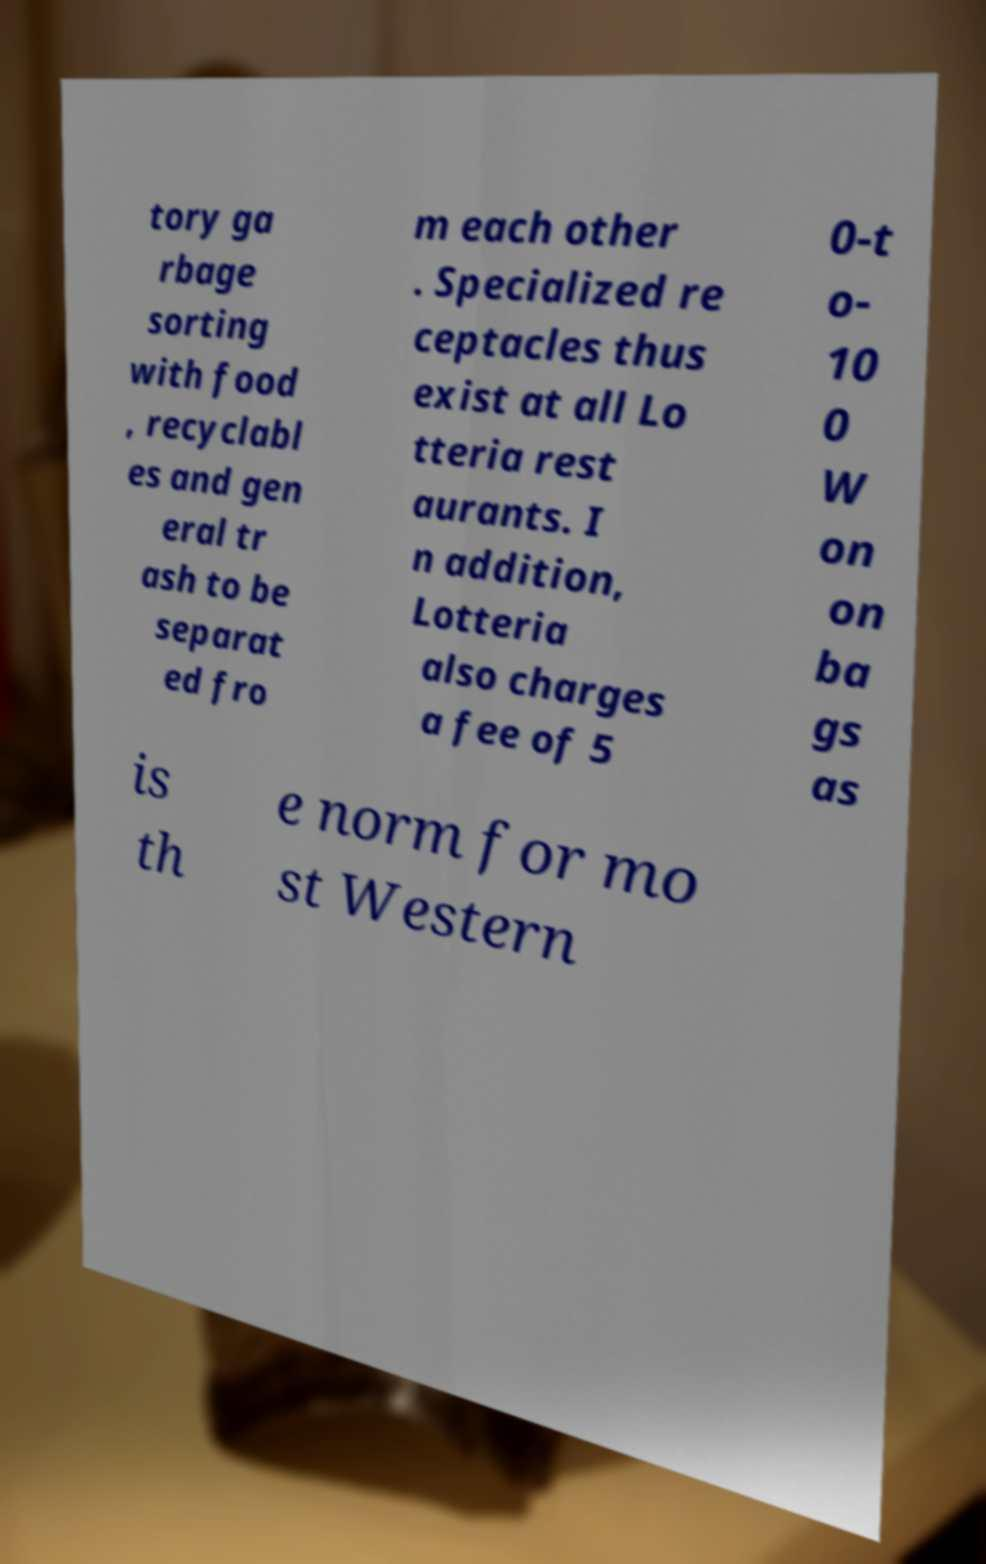Could you extract and type out the text from this image? tory ga rbage sorting with food , recyclabl es and gen eral tr ash to be separat ed fro m each other . Specialized re ceptacles thus exist at all Lo tteria rest aurants. I n addition, Lotteria also charges a fee of 5 0-t o- 10 0 W on on ba gs as is th e norm for mo st Western 